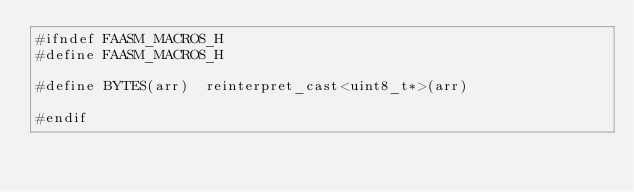Convert code to text. <code><loc_0><loc_0><loc_500><loc_500><_C_>#ifndef FAASM_MACROS_H
#define FAASM_MACROS_H

#define BYTES(arr)  reinterpret_cast<uint8_t*>(arr)

#endif
</code> 